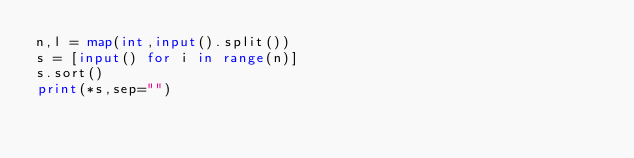<code> <loc_0><loc_0><loc_500><loc_500><_Python_>n,l = map(int,input().split())
s = [input() for i in range(n)]
s.sort()
print(*s,sep="")</code> 